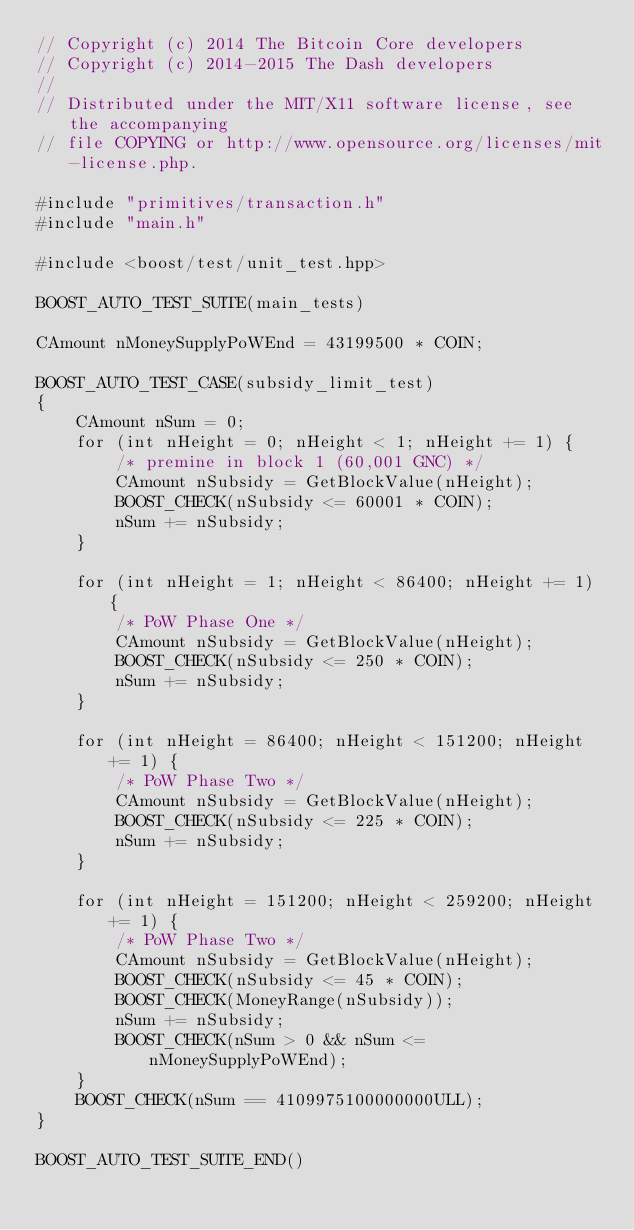<code> <loc_0><loc_0><loc_500><loc_500><_C++_>// Copyright (c) 2014 The Bitcoin Core developers
// Copyright (c) 2014-2015 The Dash developers
// 
// Distributed under the MIT/X11 software license, see the accompanying
// file COPYING or http://www.opensource.org/licenses/mit-license.php.

#include "primitives/transaction.h"
#include "main.h"

#include <boost/test/unit_test.hpp>

BOOST_AUTO_TEST_SUITE(main_tests)

CAmount nMoneySupplyPoWEnd = 43199500 * COIN;

BOOST_AUTO_TEST_CASE(subsidy_limit_test)
{
    CAmount nSum = 0;
    for (int nHeight = 0; nHeight < 1; nHeight += 1) {
        /* premine in block 1 (60,001 GNC) */
        CAmount nSubsidy = GetBlockValue(nHeight);
        BOOST_CHECK(nSubsidy <= 60001 * COIN);
        nSum += nSubsidy;
    }

    for (int nHeight = 1; nHeight < 86400; nHeight += 1) {
        /* PoW Phase One */
        CAmount nSubsidy = GetBlockValue(nHeight);
        BOOST_CHECK(nSubsidy <= 250 * COIN);
        nSum += nSubsidy;
    }

    for (int nHeight = 86400; nHeight < 151200; nHeight += 1) {
        /* PoW Phase Two */
        CAmount nSubsidy = GetBlockValue(nHeight);
        BOOST_CHECK(nSubsidy <= 225 * COIN);
        nSum += nSubsidy;
    }

    for (int nHeight = 151200; nHeight < 259200; nHeight += 1) {
        /* PoW Phase Two */
        CAmount nSubsidy = GetBlockValue(nHeight);
        BOOST_CHECK(nSubsidy <= 45 * COIN);
        BOOST_CHECK(MoneyRange(nSubsidy));
        nSum += nSubsidy;
        BOOST_CHECK(nSum > 0 && nSum <= nMoneySupplyPoWEnd);
    }
    BOOST_CHECK(nSum == 4109975100000000ULL);
}

BOOST_AUTO_TEST_SUITE_END()
</code> 